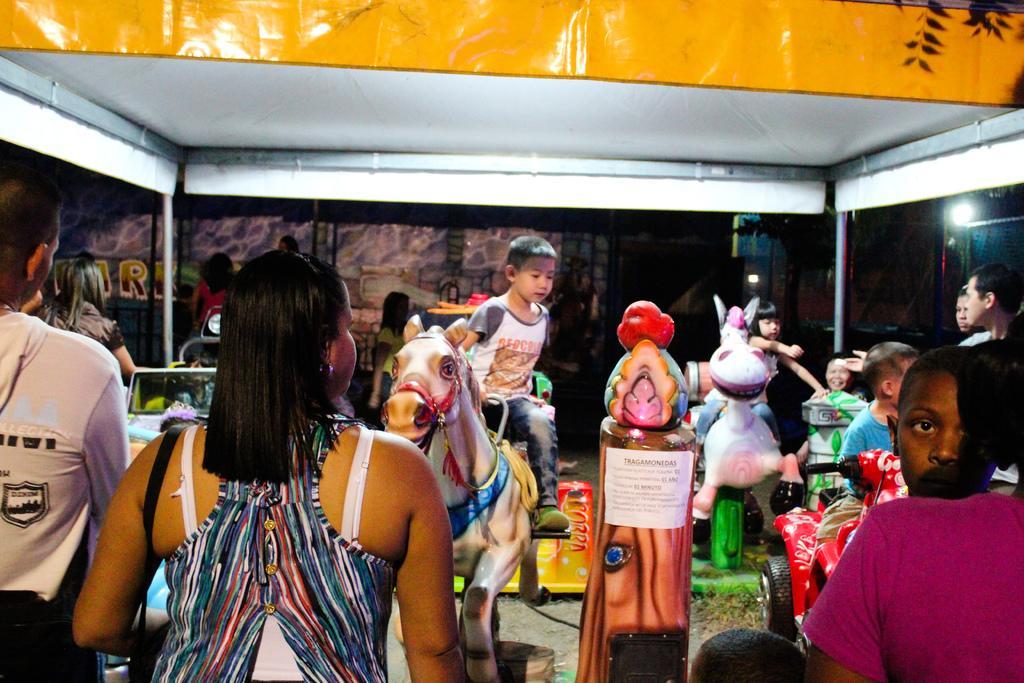Could you give a brief overview of what you see in this image? As we can see in the image there are few people standing here and there and the boy is sitting on toy horse. 